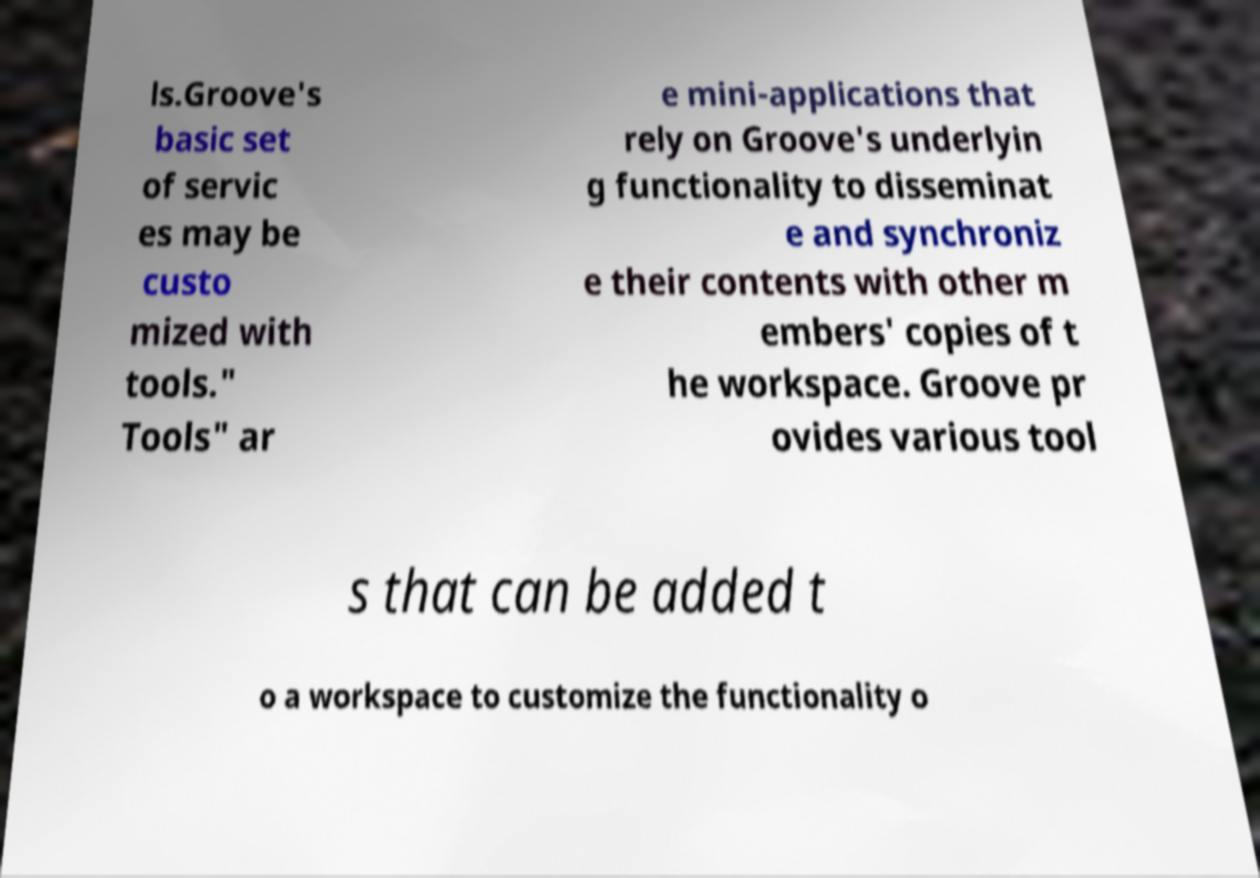Please identify and transcribe the text found in this image. ls.Groove's basic set of servic es may be custo mized with tools." Tools" ar e mini-applications that rely on Groove's underlyin g functionality to disseminat e and synchroniz e their contents with other m embers' copies of t he workspace. Groove pr ovides various tool s that can be added t o a workspace to customize the functionality o 